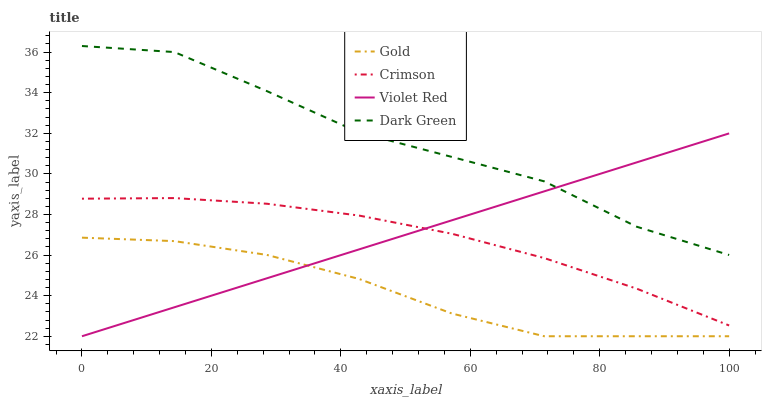Does Gold have the minimum area under the curve?
Answer yes or no. Yes. Does Dark Green have the maximum area under the curve?
Answer yes or no. Yes. Does Violet Red have the minimum area under the curve?
Answer yes or no. No. Does Violet Red have the maximum area under the curve?
Answer yes or no. No. Is Violet Red the smoothest?
Answer yes or no. Yes. Is Dark Green the roughest?
Answer yes or no. Yes. Is Gold the smoothest?
Answer yes or no. No. Is Gold the roughest?
Answer yes or no. No. Does Violet Red have the lowest value?
Answer yes or no. Yes. Does Dark Green have the lowest value?
Answer yes or no. No. Does Dark Green have the highest value?
Answer yes or no. Yes. Does Violet Red have the highest value?
Answer yes or no. No. Is Crimson less than Dark Green?
Answer yes or no. Yes. Is Dark Green greater than Crimson?
Answer yes or no. Yes. Does Crimson intersect Violet Red?
Answer yes or no. Yes. Is Crimson less than Violet Red?
Answer yes or no. No. Is Crimson greater than Violet Red?
Answer yes or no. No. Does Crimson intersect Dark Green?
Answer yes or no. No. 